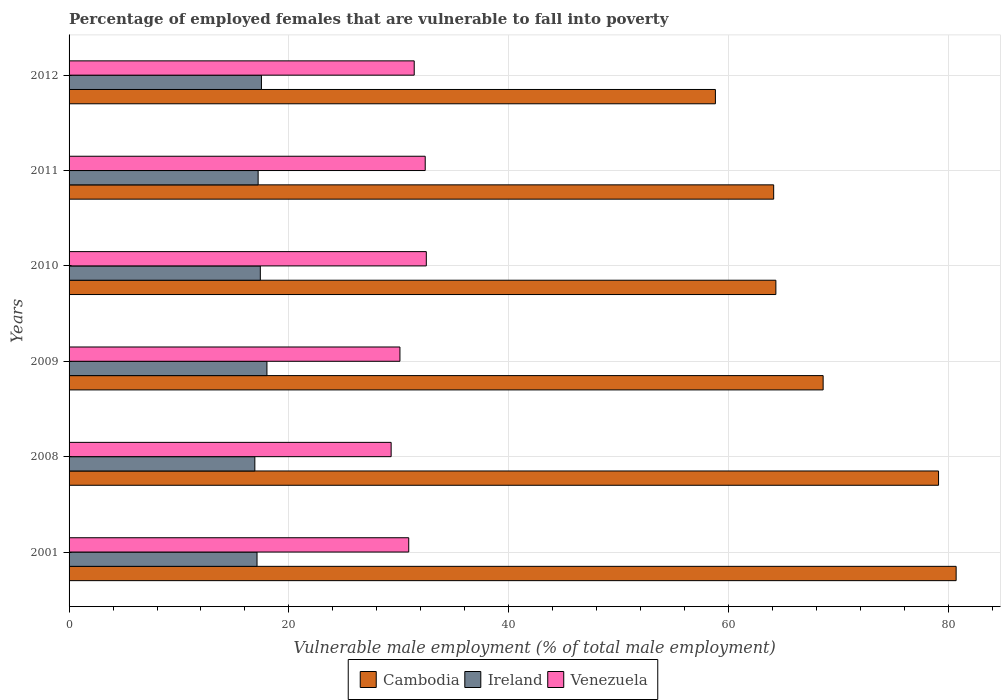How many different coloured bars are there?
Offer a terse response. 3. Are the number of bars per tick equal to the number of legend labels?
Your response must be concise. Yes. Are the number of bars on each tick of the Y-axis equal?
Provide a succinct answer. Yes. How many bars are there on the 3rd tick from the top?
Make the answer very short. 3. How many bars are there on the 2nd tick from the bottom?
Your answer should be very brief. 3. What is the percentage of employed females who are vulnerable to fall into poverty in Venezuela in 2012?
Make the answer very short. 31.4. Across all years, what is the maximum percentage of employed females who are vulnerable to fall into poverty in Ireland?
Give a very brief answer. 18. Across all years, what is the minimum percentage of employed females who are vulnerable to fall into poverty in Venezuela?
Offer a terse response. 29.3. In which year was the percentage of employed females who are vulnerable to fall into poverty in Ireland minimum?
Offer a very short reply. 2008. What is the total percentage of employed females who are vulnerable to fall into poverty in Venezuela in the graph?
Offer a very short reply. 186.6. What is the difference between the percentage of employed females who are vulnerable to fall into poverty in Venezuela in 2009 and the percentage of employed females who are vulnerable to fall into poverty in Ireland in 2001?
Make the answer very short. 13. What is the average percentage of employed females who are vulnerable to fall into poverty in Cambodia per year?
Make the answer very short. 69.27. In the year 2011, what is the difference between the percentage of employed females who are vulnerable to fall into poverty in Ireland and percentage of employed females who are vulnerable to fall into poverty in Venezuela?
Provide a short and direct response. -15.2. In how many years, is the percentage of employed females who are vulnerable to fall into poverty in Venezuela greater than 12 %?
Your response must be concise. 6. What is the ratio of the percentage of employed females who are vulnerable to fall into poverty in Venezuela in 2001 to that in 2012?
Provide a succinct answer. 0.98. Is the difference between the percentage of employed females who are vulnerable to fall into poverty in Ireland in 2001 and 2009 greater than the difference between the percentage of employed females who are vulnerable to fall into poverty in Venezuela in 2001 and 2009?
Keep it short and to the point. No. What is the difference between the highest and the second highest percentage of employed females who are vulnerable to fall into poverty in Venezuela?
Make the answer very short. 0.1. What is the difference between the highest and the lowest percentage of employed females who are vulnerable to fall into poverty in Cambodia?
Keep it short and to the point. 21.9. Is the sum of the percentage of employed females who are vulnerable to fall into poverty in Ireland in 2001 and 2008 greater than the maximum percentage of employed females who are vulnerable to fall into poverty in Cambodia across all years?
Keep it short and to the point. No. What does the 1st bar from the top in 2012 represents?
Provide a short and direct response. Venezuela. What does the 3rd bar from the bottom in 2008 represents?
Ensure brevity in your answer.  Venezuela. Is it the case that in every year, the sum of the percentage of employed females who are vulnerable to fall into poverty in Ireland and percentage of employed females who are vulnerable to fall into poverty in Venezuela is greater than the percentage of employed females who are vulnerable to fall into poverty in Cambodia?
Give a very brief answer. No. How many bars are there?
Offer a very short reply. 18. Are all the bars in the graph horizontal?
Provide a succinct answer. Yes. Are the values on the major ticks of X-axis written in scientific E-notation?
Provide a succinct answer. No. Does the graph contain any zero values?
Keep it short and to the point. No. Where does the legend appear in the graph?
Offer a terse response. Bottom center. How many legend labels are there?
Make the answer very short. 3. What is the title of the graph?
Keep it short and to the point. Percentage of employed females that are vulnerable to fall into poverty. What is the label or title of the X-axis?
Make the answer very short. Vulnerable male employment (% of total male employment). What is the label or title of the Y-axis?
Provide a short and direct response. Years. What is the Vulnerable male employment (% of total male employment) of Cambodia in 2001?
Offer a very short reply. 80.7. What is the Vulnerable male employment (% of total male employment) of Ireland in 2001?
Your response must be concise. 17.1. What is the Vulnerable male employment (% of total male employment) in Venezuela in 2001?
Offer a terse response. 30.9. What is the Vulnerable male employment (% of total male employment) in Cambodia in 2008?
Ensure brevity in your answer.  79.1. What is the Vulnerable male employment (% of total male employment) in Ireland in 2008?
Your answer should be very brief. 16.9. What is the Vulnerable male employment (% of total male employment) of Venezuela in 2008?
Offer a very short reply. 29.3. What is the Vulnerable male employment (% of total male employment) in Cambodia in 2009?
Your answer should be very brief. 68.6. What is the Vulnerable male employment (% of total male employment) in Ireland in 2009?
Provide a succinct answer. 18. What is the Vulnerable male employment (% of total male employment) in Venezuela in 2009?
Your answer should be compact. 30.1. What is the Vulnerable male employment (% of total male employment) in Cambodia in 2010?
Make the answer very short. 64.3. What is the Vulnerable male employment (% of total male employment) of Ireland in 2010?
Make the answer very short. 17.4. What is the Vulnerable male employment (% of total male employment) of Venezuela in 2010?
Your answer should be compact. 32.5. What is the Vulnerable male employment (% of total male employment) in Cambodia in 2011?
Make the answer very short. 64.1. What is the Vulnerable male employment (% of total male employment) in Ireland in 2011?
Make the answer very short. 17.2. What is the Vulnerable male employment (% of total male employment) in Venezuela in 2011?
Your response must be concise. 32.4. What is the Vulnerable male employment (% of total male employment) of Cambodia in 2012?
Your response must be concise. 58.8. What is the Vulnerable male employment (% of total male employment) of Venezuela in 2012?
Offer a terse response. 31.4. Across all years, what is the maximum Vulnerable male employment (% of total male employment) in Cambodia?
Your response must be concise. 80.7. Across all years, what is the maximum Vulnerable male employment (% of total male employment) in Venezuela?
Offer a terse response. 32.5. Across all years, what is the minimum Vulnerable male employment (% of total male employment) in Cambodia?
Your answer should be compact. 58.8. Across all years, what is the minimum Vulnerable male employment (% of total male employment) in Ireland?
Provide a short and direct response. 16.9. Across all years, what is the minimum Vulnerable male employment (% of total male employment) in Venezuela?
Your answer should be compact. 29.3. What is the total Vulnerable male employment (% of total male employment) in Cambodia in the graph?
Make the answer very short. 415.6. What is the total Vulnerable male employment (% of total male employment) in Ireland in the graph?
Make the answer very short. 104.1. What is the total Vulnerable male employment (% of total male employment) in Venezuela in the graph?
Offer a very short reply. 186.6. What is the difference between the Vulnerable male employment (% of total male employment) in Cambodia in 2001 and that in 2008?
Offer a very short reply. 1.6. What is the difference between the Vulnerable male employment (% of total male employment) of Ireland in 2001 and that in 2008?
Your answer should be compact. 0.2. What is the difference between the Vulnerable male employment (% of total male employment) in Venezuela in 2001 and that in 2009?
Your answer should be very brief. 0.8. What is the difference between the Vulnerable male employment (% of total male employment) in Cambodia in 2001 and that in 2010?
Your answer should be compact. 16.4. What is the difference between the Vulnerable male employment (% of total male employment) of Venezuela in 2001 and that in 2010?
Provide a short and direct response. -1.6. What is the difference between the Vulnerable male employment (% of total male employment) of Cambodia in 2001 and that in 2011?
Give a very brief answer. 16.6. What is the difference between the Vulnerable male employment (% of total male employment) in Ireland in 2001 and that in 2011?
Offer a very short reply. -0.1. What is the difference between the Vulnerable male employment (% of total male employment) in Venezuela in 2001 and that in 2011?
Your response must be concise. -1.5. What is the difference between the Vulnerable male employment (% of total male employment) in Cambodia in 2001 and that in 2012?
Your response must be concise. 21.9. What is the difference between the Vulnerable male employment (% of total male employment) of Ireland in 2001 and that in 2012?
Provide a short and direct response. -0.4. What is the difference between the Vulnerable male employment (% of total male employment) of Cambodia in 2008 and that in 2009?
Ensure brevity in your answer.  10.5. What is the difference between the Vulnerable male employment (% of total male employment) in Venezuela in 2008 and that in 2009?
Provide a short and direct response. -0.8. What is the difference between the Vulnerable male employment (% of total male employment) in Ireland in 2008 and that in 2010?
Your answer should be compact. -0.5. What is the difference between the Vulnerable male employment (% of total male employment) of Venezuela in 2008 and that in 2010?
Offer a very short reply. -3.2. What is the difference between the Vulnerable male employment (% of total male employment) of Cambodia in 2008 and that in 2011?
Make the answer very short. 15. What is the difference between the Vulnerable male employment (% of total male employment) in Venezuela in 2008 and that in 2011?
Keep it short and to the point. -3.1. What is the difference between the Vulnerable male employment (% of total male employment) of Cambodia in 2008 and that in 2012?
Give a very brief answer. 20.3. What is the difference between the Vulnerable male employment (% of total male employment) of Ireland in 2008 and that in 2012?
Offer a terse response. -0.6. What is the difference between the Vulnerable male employment (% of total male employment) of Venezuela in 2009 and that in 2010?
Your answer should be compact. -2.4. What is the difference between the Vulnerable male employment (% of total male employment) in Cambodia in 2009 and that in 2011?
Your response must be concise. 4.5. What is the difference between the Vulnerable male employment (% of total male employment) in Ireland in 2009 and that in 2011?
Your answer should be very brief. 0.8. What is the difference between the Vulnerable male employment (% of total male employment) in Venezuela in 2009 and that in 2011?
Ensure brevity in your answer.  -2.3. What is the difference between the Vulnerable male employment (% of total male employment) in Cambodia in 2010 and that in 2011?
Provide a succinct answer. 0.2. What is the difference between the Vulnerable male employment (% of total male employment) in Venezuela in 2010 and that in 2011?
Ensure brevity in your answer.  0.1. What is the difference between the Vulnerable male employment (% of total male employment) of Cambodia in 2010 and that in 2012?
Your answer should be very brief. 5.5. What is the difference between the Vulnerable male employment (% of total male employment) in Venezuela in 2010 and that in 2012?
Keep it short and to the point. 1.1. What is the difference between the Vulnerable male employment (% of total male employment) of Ireland in 2011 and that in 2012?
Keep it short and to the point. -0.3. What is the difference between the Vulnerable male employment (% of total male employment) of Cambodia in 2001 and the Vulnerable male employment (% of total male employment) of Ireland in 2008?
Provide a succinct answer. 63.8. What is the difference between the Vulnerable male employment (% of total male employment) of Cambodia in 2001 and the Vulnerable male employment (% of total male employment) of Venezuela in 2008?
Ensure brevity in your answer.  51.4. What is the difference between the Vulnerable male employment (% of total male employment) of Cambodia in 2001 and the Vulnerable male employment (% of total male employment) of Ireland in 2009?
Your response must be concise. 62.7. What is the difference between the Vulnerable male employment (% of total male employment) of Cambodia in 2001 and the Vulnerable male employment (% of total male employment) of Venezuela in 2009?
Make the answer very short. 50.6. What is the difference between the Vulnerable male employment (% of total male employment) of Cambodia in 2001 and the Vulnerable male employment (% of total male employment) of Ireland in 2010?
Your response must be concise. 63.3. What is the difference between the Vulnerable male employment (% of total male employment) in Cambodia in 2001 and the Vulnerable male employment (% of total male employment) in Venezuela in 2010?
Make the answer very short. 48.2. What is the difference between the Vulnerable male employment (% of total male employment) of Ireland in 2001 and the Vulnerable male employment (% of total male employment) of Venezuela in 2010?
Provide a succinct answer. -15.4. What is the difference between the Vulnerable male employment (% of total male employment) of Cambodia in 2001 and the Vulnerable male employment (% of total male employment) of Ireland in 2011?
Make the answer very short. 63.5. What is the difference between the Vulnerable male employment (% of total male employment) in Cambodia in 2001 and the Vulnerable male employment (% of total male employment) in Venezuela in 2011?
Give a very brief answer. 48.3. What is the difference between the Vulnerable male employment (% of total male employment) in Ireland in 2001 and the Vulnerable male employment (% of total male employment) in Venezuela in 2011?
Keep it short and to the point. -15.3. What is the difference between the Vulnerable male employment (% of total male employment) in Cambodia in 2001 and the Vulnerable male employment (% of total male employment) in Ireland in 2012?
Give a very brief answer. 63.2. What is the difference between the Vulnerable male employment (% of total male employment) in Cambodia in 2001 and the Vulnerable male employment (% of total male employment) in Venezuela in 2012?
Give a very brief answer. 49.3. What is the difference between the Vulnerable male employment (% of total male employment) of Ireland in 2001 and the Vulnerable male employment (% of total male employment) of Venezuela in 2012?
Provide a short and direct response. -14.3. What is the difference between the Vulnerable male employment (% of total male employment) in Cambodia in 2008 and the Vulnerable male employment (% of total male employment) in Ireland in 2009?
Offer a terse response. 61.1. What is the difference between the Vulnerable male employment (% of total male employment) in Cambodia in 2008 and the Vulnerable male employment (% of total male employment) in Venezuela in 2009?
Your answer should be very brief. 49. What is the difference between the Vulnerable male employment (% of total male employment) of Cambodia in 2008 and the Vulnerable male employment (% of total male employment) of Ireland in 2010?
Offer a very short reply. 61.7. What is the difference between the Vulnerable male employment (% of total male employment) of Cambodia in 2008 and the Vulnerable male employment (% of total male employment) of Venezuela in 2010?
Ensure brevity in your answer.  46.6. What is the difference between the Vulnerable male employment (% of total male employment) in Ireland in 2008 and the Vulnerable male employment (% of total male employment) in Venezuela in 2010?
Provide a succinct answer. -15.6. What is the difference between the Vulnerable male employment (% of total male employment) of Cambodia in 2008 and the Vulnerable male employment (% of total male employment) of Ireland in 2011?
Your answer should be compact. 61.9. What is the difference between the Vulnerable male employment (% of total male employment) of Cambodia in 2008 and the Vulnerable male employment (% of total male employment) of Venezuela in 2011?
Keep it short and to the point. 46.7. What is the difference between the Vulnerable male employment (% of total male employment) in Ireland in 2008 and the Vulnerable male employment (% of total male employment) in Venezuela in 2011?
Ensure brevity in your answer.  -15.5. What is the difference between the Vulnerable male employment (% of total male employment) of Cambodia in 2008 and the Vulnerable male employment (% of total male employment) of Ireland in 2012?
Your answer should be very brief. 61.6. What is the difference between the Vulnerable male employment (% of total male employment) of Cambodia in 2008 and the Vulnerable male employment (% of total male employment) of Venezuela in 2012?
Your answer should be very brief. 47.7. What is the difference between the Vulnerable male employment (% of total male employment) in Cambodia in 2009 and the Vulnerable male employment (% of total male employment) in Ireland in 2010?
Ensure brevity in your answer.  51.2. What is the difference between the Vulnerable male employment (% of total male employment) of Cambodia in 2009 and the Vulnerable male employment (% of total male employment) of Venezuela in 2010?
Your answer should be compact. 36.1. What is the difference between the Vulnerable male employment (% of total male employment) in Cambodia in 2009 and the Vulnerable male employment (% of total male employment) in Ireland in 2011?
Offer a very short reply. 51.4. What is the difference between the Vulnerable male employment (% of total male employment) in Cambodia in 2009 and the Vulnerable male employment (% of total male employment) in Venezuela in 2011?
Your response must be concise. 36.2. What is the difference between the Vulnerable male employment (% of total male employment) in Ireland in 2009 and the Vulnerable male employment (% of total male employment) in Venezuela in 2011?
Offer a very short reply. -14.4. What is the difference between the Vulnerable male employment (% of total male employment) of Cambodia in 2009 and the Vulnerable male employment (% of total male employment) of Ireland in 2012?
Keep it short and to the point. 51.1. What is the difference between the Vulnerable male employment (% of total male employment) of Cambodia in 2009 and the Vulnerable male employment (% of total male employment) of Venezuela in 2012?
Give a very brief answer. 37.2. What is the difference between the Vulnerable male employment (% of total male employment) of Ireland in 2009 and the Vulnerable male employment (% of total male employment) of Venezuela in 2012?
Offer a terse response. -13.4. What is the difference between the Vulnerable male employment (% of total male employment) of Cambodia in 2010 and the Vulnerable male employment (% of total male employment) of Ireland in 2011?
Ensure brevity in your answer.  47.1. What is the difference between the Vulnerable male employment (% of total male employment) in Cambodia in 2010 and the Vulnerable male employment (% of total male employment) in Venezuela in 2011?
Your response must be concise. 31.9. What is the difference between the Vulnerable male employment (% of total male employment) of Ireland in 2010 and the Vulnerable male employment (% of total male employment) of Venezuela in 2011?
Ensure brevity in your answer.  -15. What is the difference between the Vulnerable male employment (% of total male employment) in Cambodia in 2010 and the Vulnerable male employment (% of total male employment) in Ireland in 2012?
Your answer should be compact. 46.8. What is the difference between the Vulnerable male employment (% of total male employment) in Cambodia in 2010 and the Vulnerable male employment (% of total male employment) in Venezuela in 2012?
Offer a very short reply. 32.9. What is the difference between the Vulnerable male employment (% of total male employment) of Ireland in 2010 and the Vulnerable male employment (% of total male employment) of Venezuela in 2012?
Offer a terse response. -14. What is the difference between the Vulnerable male employment (% of total male employment) in Cambodia in 2011 and the Vulnerable male employment (% of total male employment) in Ireland in 2012?
Keep it short and to the point. 46.6. What is the difference between the Vulnerable male employment (% of total male employment) in Cambodia in 2011 and the Vulnerable male employment (% of total male employment) in Venezuela in 2012?
Ensure brevity in your answer.  32.7. What is the average Vulnerable male employment (% of total male employment) of Cambodia per year?
Provide a short and direct response. 69.27. What is the average Vulnerable male employment (% of total male employment) of Ireland per year?
Give a very brief answer. 17.35. What is the average Vulnerable male employment (% of total male employment) in Venezuela per year?
Your response must be concise. 31.1. In the year 2001, what is the difference between the Vulnerable male employment (% of total male employment) in Cambodia and Vulnerable male employment (% of total male employment) in Ireland?
Provide a short and direct response. 63.6. In the year 2001, what is the difference between the Vulnerable male employment (% of total male employment) in Cambodia and Vulnerable male employment (% of total male employment) in Venezuela?
Make the answer very short. 49.8. In the year 2008, what is the difference between the Vulnerable male employment (% of total male employment) of Cambodia and Vulnerable male employment (% of total male employment) of Ireland?
Provide a short and direct response. 62.2. In the year 2008, what is the difference between the Vulnerable male employment (% of total male employment) in Cambodia and Vulnerable male employment (% of total male employment) in Venezuela?
Make the answer very short. 49.8. In the year 2008, what is the difference between the Vulnerable male employment (% of total male employment) in Ireland and Vulnerable male employment (% of total male employment) in Venezuela?
Keep it short and to the point. -12.4. In the year 2009, what is the difference between the Vulnerable male employment (% of total male employment) in Cambodia and Vulnerable male employment (% of total male employment) in Ireland?
Ensure brevity in your answer.  50.6. In the year 2009, what is the difference between the Vulnerable male employment (% of total male employment) of Cambodia and Vulnerable male employment (% of total male employment) of Venezuela?
Make the answer very short. 38.5. In the year 2009, what is the difference between the Vulnerable male employment (% of total male employment) of Ireland and Vulnerable male employment (% of total male employment) of Venezuela?
Your response must be concise. -12.1. In the year 2010, what is the difference between the Vulnerable male employment (% of total male employment) of Cambodia and Vulnerable male employment (% of total male employment) of Ireland?
Your response must be concise. 46.9. In the year 2010, what is the difference between the Vulnerable male employment (% of total male employment) of Cambodia and Vulnerable male employment (% of total male employment) of Venezuela?
Provide a succinct answer. 31.8. In the year 2010, what is the difference between the Vulnerable male employment (% of total male employment) in Ireland and Vulnerable male employment (% of total male employment) in Venezuela?
Offer a very short reply. -15.1. In the year 2011, what is the difference between the Vulnerable male employment (% of total male employment) of Cambodia and Vulnerable male employment (% of total male employment) of Ireland?
Give a very brief answer. 46.9. In the year 2011, what is the difference between the Vulnerable male employment (% of total male employment) in Cambodia and Vulnerable male employment (% of total male employment) in Venezuela?
Offer a very short reply. 31.7. In the year 2011, what is the difference between the Vulnerable male employment (% of total male employment) in Ireland and Vulnerable male employment (% of total male employment) in Venezuela?
Offer a terse response. -15.2. In the year 2012, what is the difference between the Vulnerable male employment (% of total male employment) in Cambodia and Vulnerable male employment (% of total male employment) in Ireland?
Keep it short and to the point. 41.3. In the year 2012, what is the difference between the Vulnerable male employment (% of total male employment) of Cambodia and Vulnerable male employment (% of total male employment) of Venezuela?
Offer a terse response. 27.4. In the year 2012, what is the difference between the Vulnerable male employment (% of total male employment) in Ireland and Vulnerable male employment (% of total male employment) in Venezuela?
Make the answer very short. -13.9. What is the ratio of the Vulnerable male employment (% of total male employment) in Cambodia in 2001 to that in 2008?
Your response must be concise. 1.02. What is the ratio of the Vulnerable male employment (% of total male employment) of Ireland in 2001 to that in 2008?
Provide a succinct answer. 1.01. What is the ratio of the Vulnerable male employment (% of total male employment) in Venezuela in 2001 to that in 2008?
Make the answer very short. 1.05. What is the ratio of the Vulnerable male employment (% of total male employment) in Cambodia in 2001 to that in 2009?
Give a very brief answer. 1.18. What is the ratio of the Vulnerable male employment (% of total male employment) in Venezuela in 2001 to that in 2009?
Offer a very short reply. 1.03. What is the ratio of the Vulnerable male employment (% of total male employment) of Cambodia in 2001 to that in 2010?
Offer a terse response. 1.26. What is the ratio of the Vulnerable male employment (% of total male employment) in Ireland in 2001 to that in 2010?
Give a very brief answer. 0.98. What is the ratio of the Vulnerable male employment (% of total male employment) of Venezuela in 2001 to that in 2010?
Ensure brevity in your answer.  0.95. What is the ratio of the Vulnerable male employment (% of total male employment) in Cambodia in 2001 to that in 2011?
Ensure brevity in your answer.  1.26. What is the ratio of the Vulnerable male employment (% of total male employment) in Venezuela in 2001 to that in 2011?
Your answer should be compact. 0.95. What is the ratio of the Vulnerable male employment (% of total male employment) of Cambodia in 2001 to that in 2012?
Provide a short and direct response. 1.37. What is the ratio of the Vulnerable male employment (% of total male employment) in Ireland in 2001 to that in 2012?
Your response must be concise. 0.98. What is the ratio of the Vulnerable male employment (% of total male employment) in Venezuela in 2001 to that in 2012?
Your response must be concise. 0.98. What is the ratio of the Vulnerable male employment (% of total male employment) in Cambodia in 2008 to that in 2009?
Ensure brevity in your answer.  1.15. What is the ratio of the Vulnerable male employment (% of total male employment) in Ireland in 2008 to that in 2009?
Your answer should be very brief. 0.94. What is the ratio of the Vulnerable male employment (% of total male employment) of Venezuela in 2008 to that in 2009?
Offer a terse response. 0.97. What is the ratio of the Vulnerable male employment (% of total male employment) in Cambodia in 2008 to that in 2010?
Provide a short and direct response. 1.23. What is the ratio of the Vulnerable male employment (% of total male employment) in Ireland in 2008 to that in 2010?
Provide a succinct answer. 0.97. What is the ratio of the Vulnerable male employment (% of total male employment) in Venezuela in 2008 to that in 2010?
Your answer should be very brief. 0.9. What is the ratio of the Vulnerable male employment (% of total male employment) in Cambodia in 2008 to that in 2011?
Your answer should be compact. 1.23. What is the ratio of the Vulnerable male employment (% of total male employment) of Ireland in 2008 to that in 2011?
Your answer should be compact. 0.98. What is the ratio of the Vulnerable male employment (% of total male employment) in Venezuela in 2008 to that in 2011?
Ensure brevity in your answer.  0.9. What is the ratio of the Vulnerable male employment (% of total male employment) of Cambodia in 2008 to that in 2012?
Make the answer very short. 1.35. What is the ratio of the Vulnerable male employment (% of total male employment) in Ireland in 2008 to that in 2012?
Provide a short and direct response. 0.97. What is the ratio of the Vulnerable male employment (% of total male employment) in Venezuela in 2008 to that in 2012?
Your answer should be compact. 0.93. What is the ratio of the Vulnerable male employment (% of total male employment) of Cambodia in 2009 to that in 2010?
Offer a terse response. 1.07. What is the ratio of the Vulnerable male employment (% of total male employment) in Ireland in 2009 to that in 2010?
Make the answer very short. 1.03. What is the ratio of the Vulnerable male employment (% of total male employment) in Venezuela in 2009 to that in 2010?
Your answer should be compact. 0.93. What is the ratio of the Vulnerable male employment (% of total male employment) of Cambodia in 2009 to that in 2011?
Keep it short and to the point. 1.07. What is the ratio of the Vulnerable male employment (% of total male employment) of Ireland in 2009 to that in 2011?
Offer a terse response. 1.05. What is the ratio of the Vulnerable male employment (% of total male employment) of Venezuela in 2009 to that in 2011?
Make the answer very short. 0.93. What is the ratio of the Vulnerable male employment (% of total male employment) of Cambodia in 2009 to that in 2012?
Provide a short and direct response. 1.17. What is the ratio of the Vulnerable male employment (% of total male employment) in Ireland in 2009 to that in 2012?
Provide a short and direct response. 1.03. What is the ratio of the Vulnerable male employment (% of total male employment) of Venezuela in 2009 to that in 2012?
Provide a short and direct response. 0.96. What is the ratio of the Vulnerable male employment (% of total male employment) in Cambodia in 2010 to that in 2011?
Provide a succinct answer. 1. What is the ratio of the Vulnerable male employment (% of total male employment) in Ireland in 2010 to that in 2011?
Make the answer very short. 1.01. What is the ratio of the Vulnerable male employment (% of total male employment) of Cambodia in 2010 to that in 2012?
Give a very brief answer. 1.09. What is the ratio of the Vulnerable male employment (% of total male employment) in Venezuela in 2010 to that in 2012?
Your answer should be very brief. 1.03. What is the ratio of the Vulnerable male employment (% of total male employment) of Cambodia in 2011 to that in 2012?
Keep it short and to the point. 1.09. What is the ratio of the Vulnerable male employment (% of total male employment) of Ireland in 2011 to that in 2012?
Your answer should be very brief. 0.98. What is the ratio of the Vulnerable male employment (% of total male employment) of Venezuela in 2011 to that in 2012?
Make the answer very short. 1.03. What is the difference between the highest and the second highest Vulnerable male employment (% of total male employment) of Cambodia?
Provide a short and direct response. 1.6. What is the difference between the highest and the second highest Vulnerable male employment (% of total male employment) in Ireland?
Your response must be concise. 0.5. What is the difference between the highest and the lowest Vulnerable male employment (% of total male employment) in Cambodia?
Offer a terse response. 21.9. What is the difference between the highest and the lowest Vulnerable male employment (% of total male employment) of Venezuela?
Ensure brevity in your answer.  3.2. 